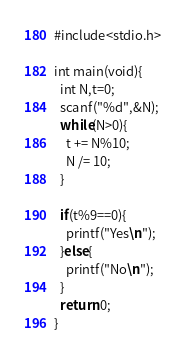<code> <loc_0><loc_0><loc_500><loc_500><_C_>#include<stdio.h>
 
int main(void){
  int N,t=0;
  scanf("%d",&N);
  while(N>0){
    t += N%10;
    N /= 10;
  }
  
  if(t%9==0){
    printf("Yes\n");
  }else{
    printf("No\n");
  }
  return 0;
}</code> 